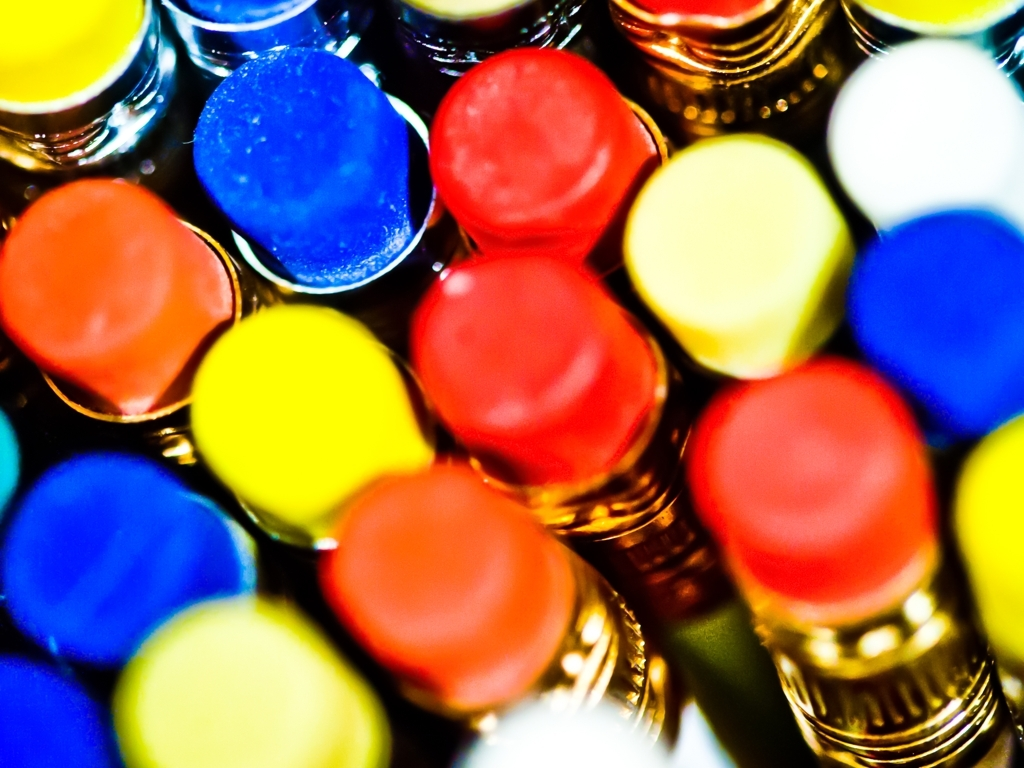What kind of mood or atmosphere does this image evoke? The image evokes a sense of playfulness and creativity, largely due to the bright and saturated colors. Such a palette often inspires a positive emotional response, which can be associated with joy, energy, and a stimulating visual experience. The selective focus adds a dreamy or whimsical quality to the image. 